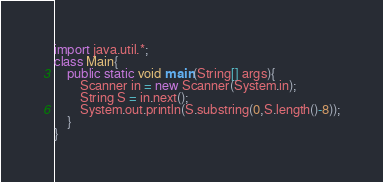<code> <loc_0><loc_0><loc_500><loc_500><_Java_>import java.util.*;
class Main{
	public static void main(String[] args){
		Scanner in = new Scanner(System.in);
		String S = in.next();
		System.out.println(S.substring(0,S.length()-8));
	}
}</code> 